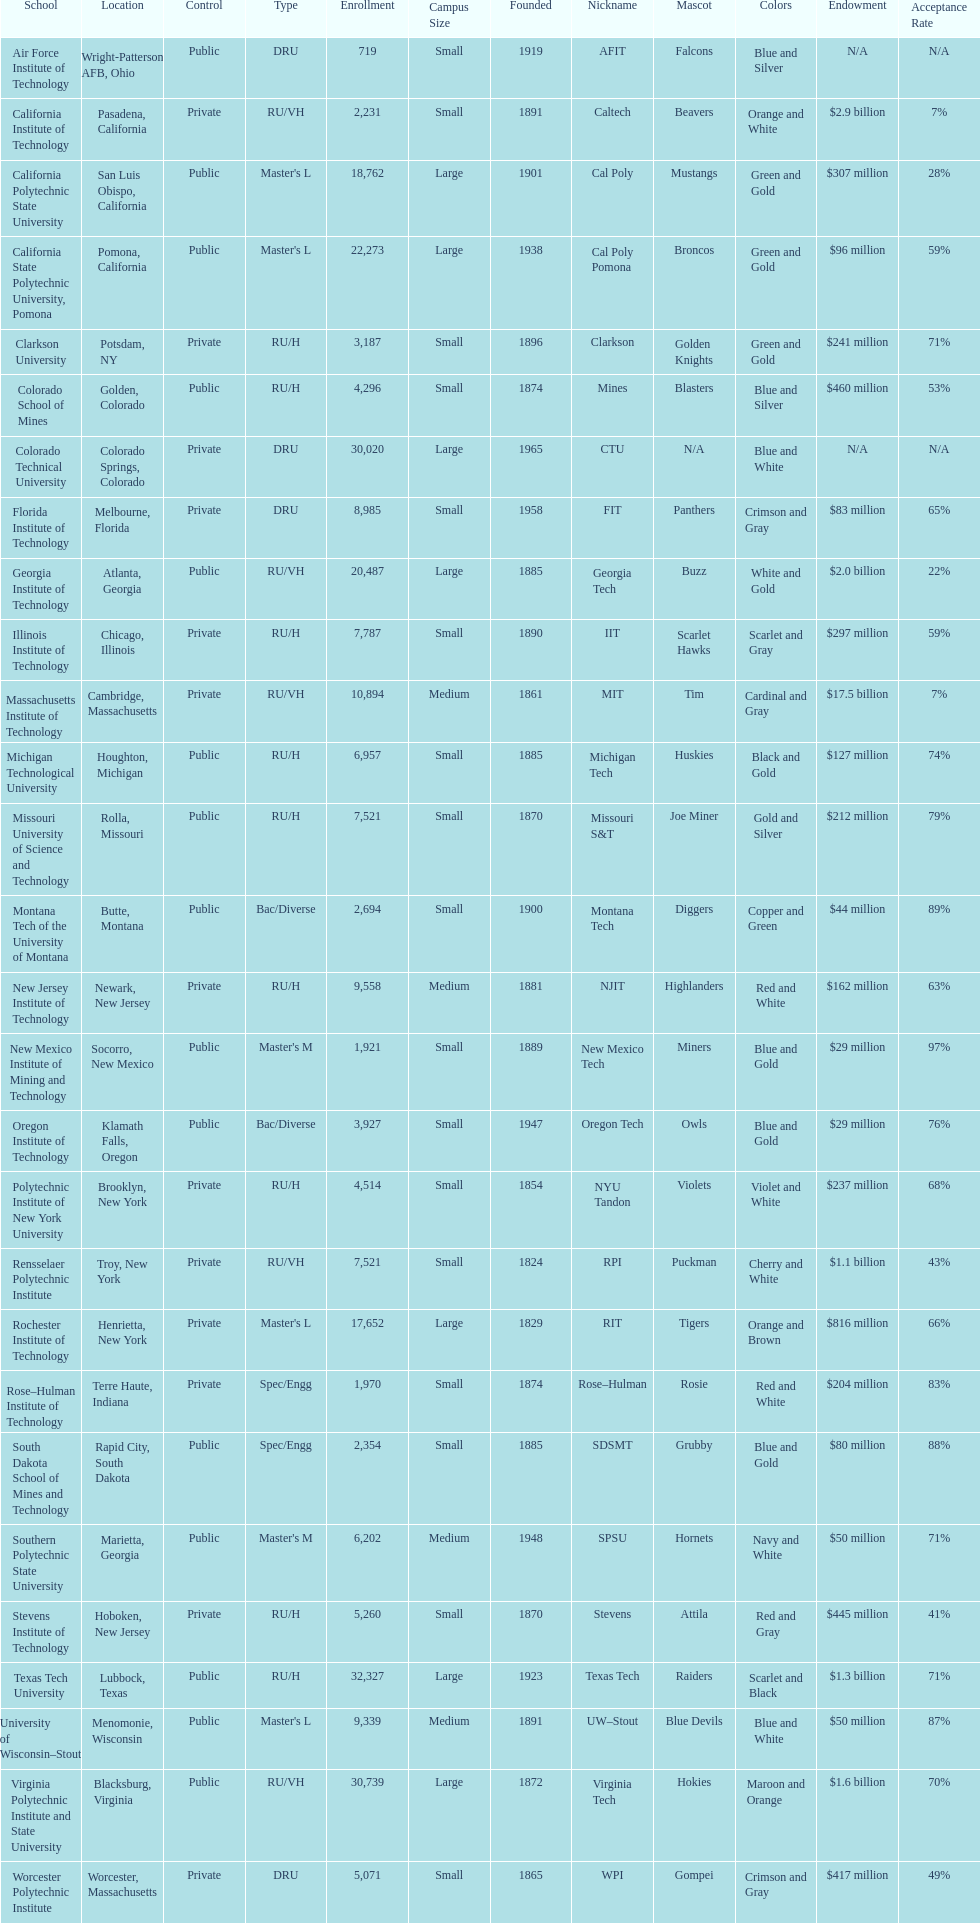What is the quantity of schools displayed in the table? 28. 